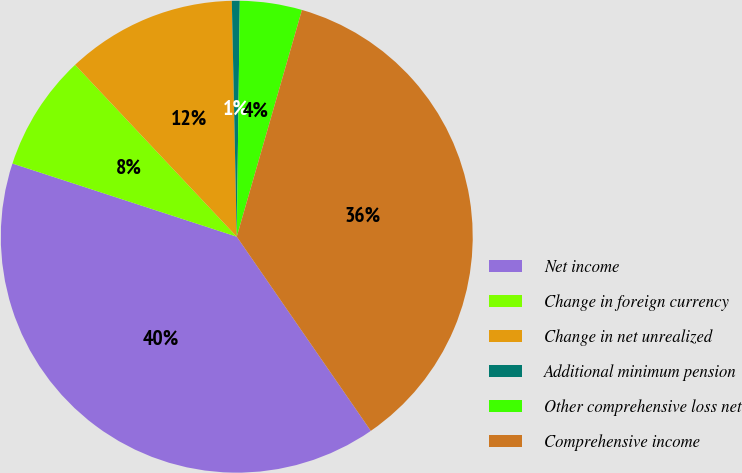Convert chart to OTSL. <chart><loc_0><loc_0><loc_500><loc_500><pie_chart><fcel>Net income<fcel>Change in foreign currency<fcel>Change in net unrealized<fcel>Additional minimum pension<fcel>Other comprehensive loss net<fcel>Comprehensive income<nl><fcel>39.64%<fcel>7.97%<fcel>11.68%<fcel>0.54%<fcel>4.25%<fcel>35.93%<nl></chart> 